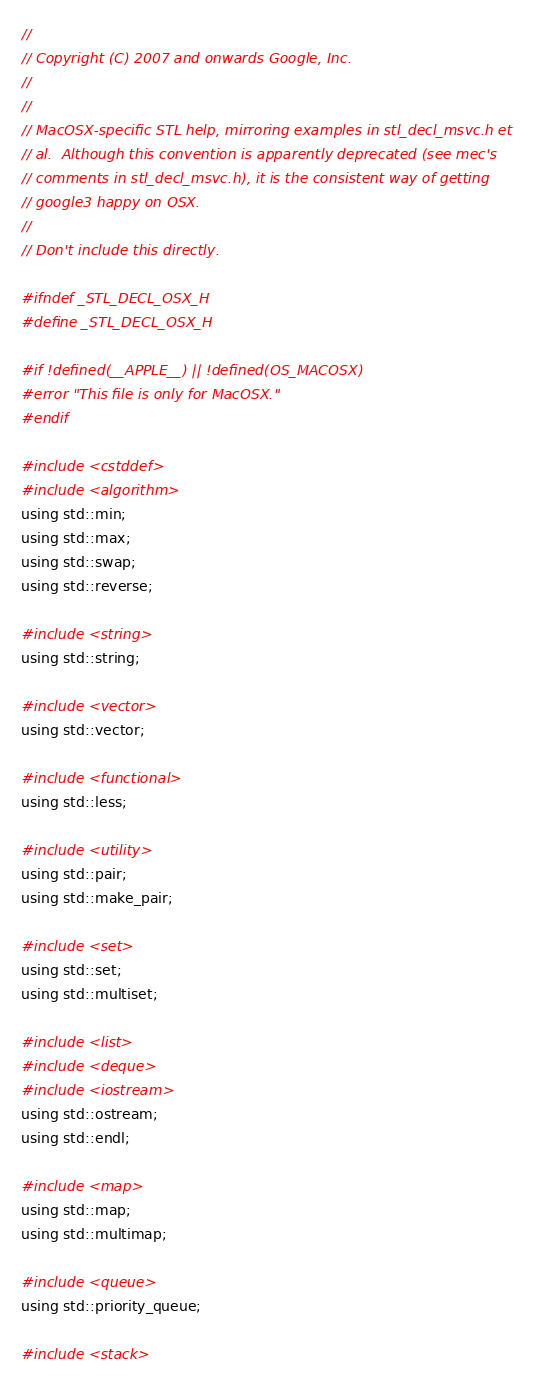<code> <loc_0><loc_0><loc_500><loc_500><_C_>//
// Copyright (C) 2007 and onwards Google, Inc.
//
//
// MacOSX-specific STL help, mirroring examples in stl_decl_msvc.h et
// al.  Although this convention is apparently deprecated (see mec's
// comments in stl_decl_msvc.h), it is the consistent way of getting
// google3 happy on OSX.
//
// Don't include this directly.

#ifndef _STL_DECL_OSX_H
#define _STL_DECL_OSX_H

#if !defined(__APPLE__) || !defined(OS_MACOSX)
#error "This file is only for MacOSX."
#endif

#include <cstddef>
#include <algorithm>
using std::min;
using std::max;
using std::swap;
using std::reverse;

#include <string>
using std::string;

#include <vector>
using std::vector;

#include <functional>
using std::less;

#include <utility>
using std::pair;
using std::make_pair;

#include <set>
using std::set;
using std::multiset;

#include <list>
#include <deque>
#include <iostream>
using std::ostream;
using std::endl;

#include <map>
using std::map;
using std::multimap;

#include <queue>
using std::priority_queue;

#include <stack></code> 